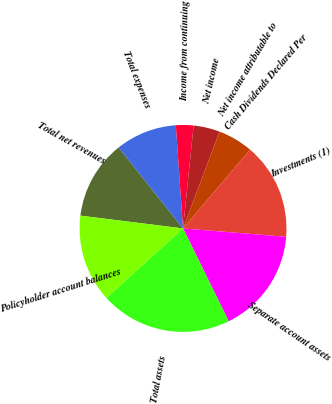Convert chart. <chart><loc_0><loc_0><loc_500><loc_500><pie_chart><fcel>Total net revenues<fcel>Total expenses<fcel>Income from continuing<fcel>Net income<fcel>Net income attributable to<fcel>Cash Dividends Declared Per<fcel>Investments (1)<fcel>Separate account assets<fcel>Total assets<fcel>Policyholder account balances<nl><fcel>12.33%<fcel>9.59%<fcel>2.74%<fcel>4.11%<fcel>5.48%<fcel>0.0%<fcel>15.07%<fcel>16.44%<fcel>20.55%<fcel>13.7%<nl></chart> 